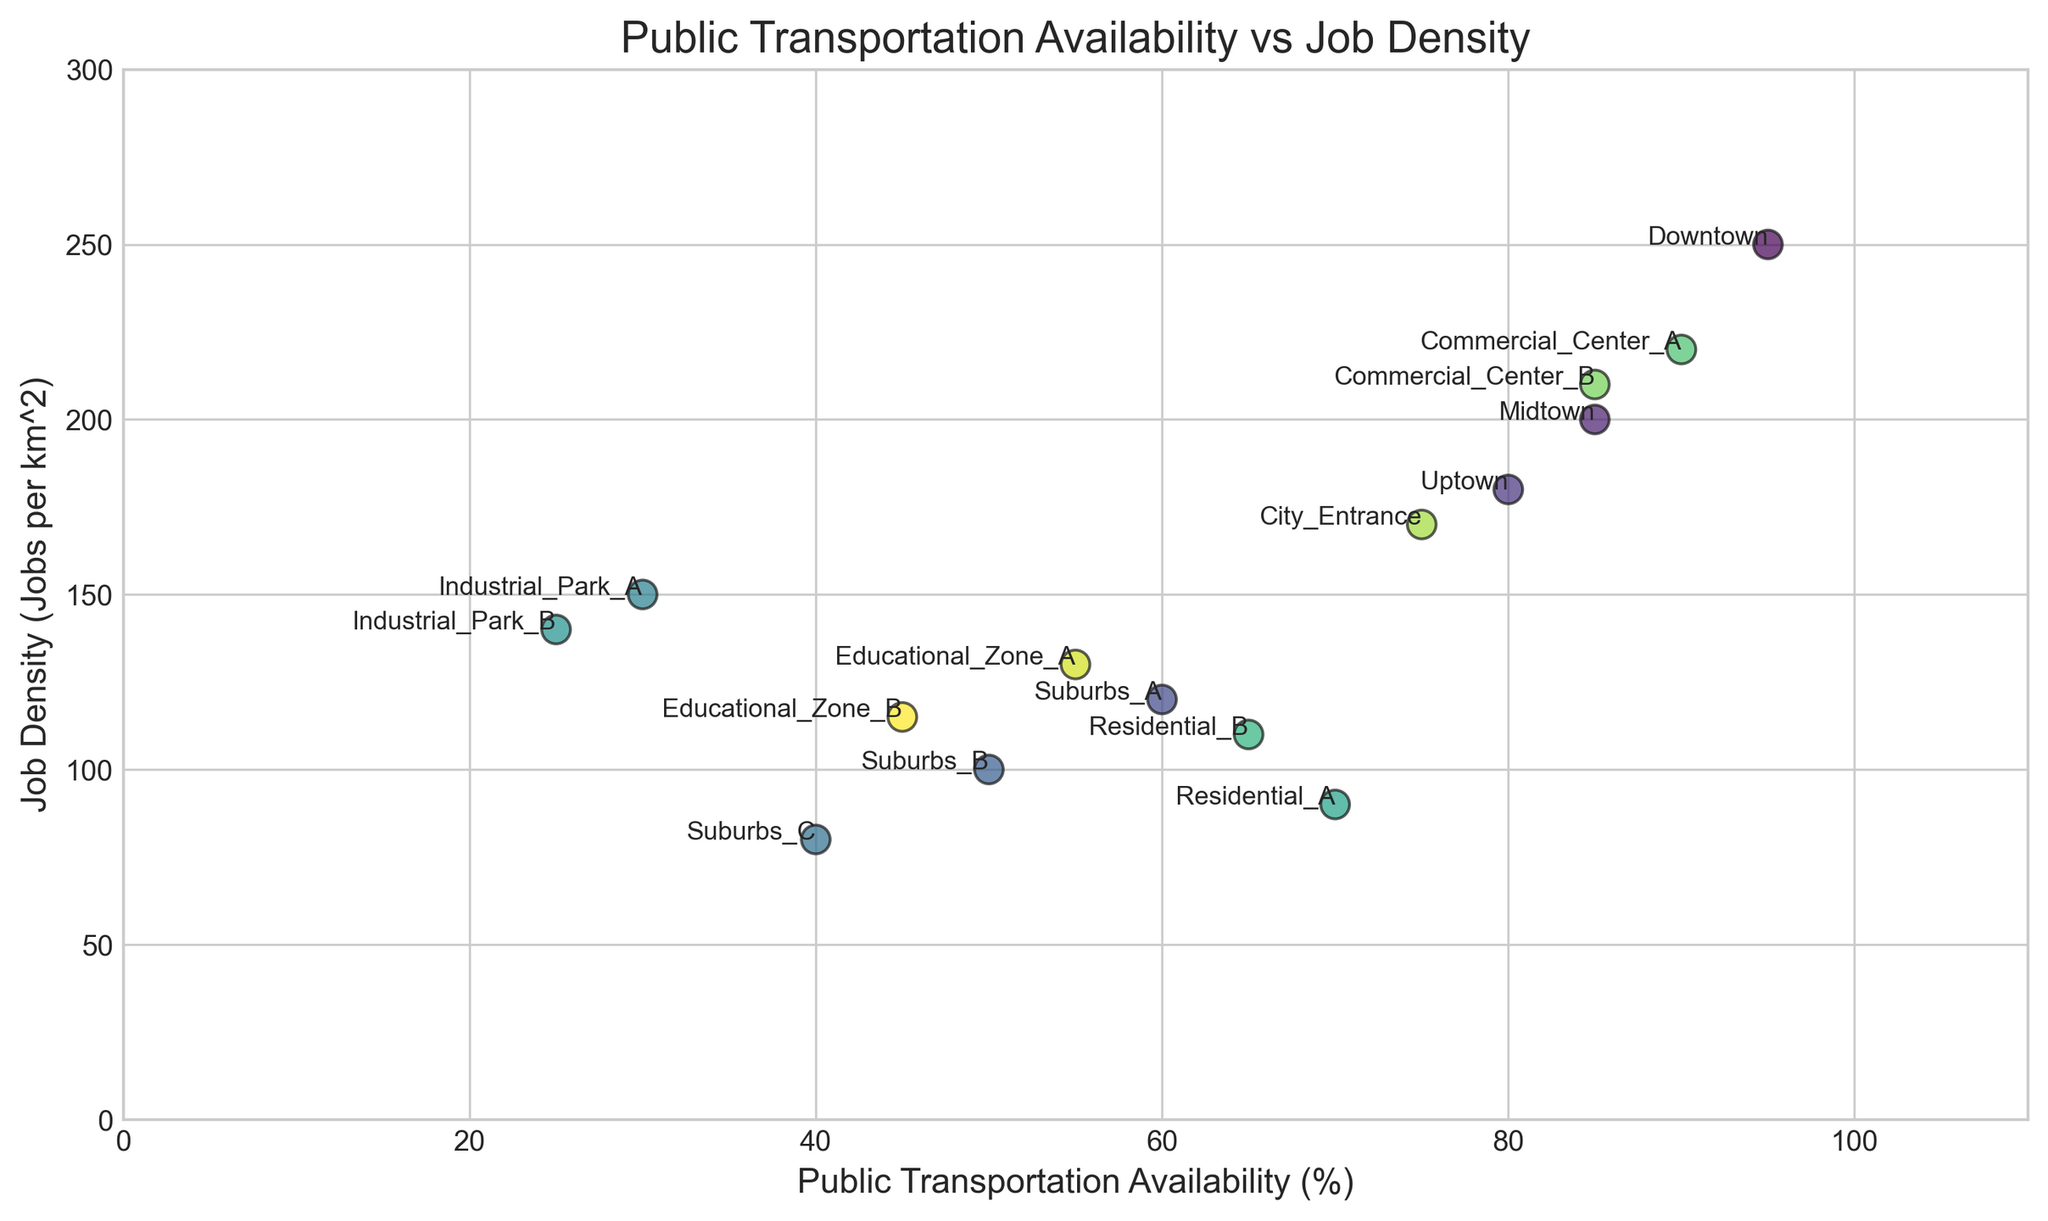What area has the highest job density? Look at the point with the highest vertical position on the y-axis representing job density. The area labeled "Downtown" is at the topmost vertical position indicating it has the highest job density.
Answer: Downtown Which area has the least availability of public transportation? Identify the point with the lowest horizontal position on the x-axis representing public transportation availability. The area labeled "Industrial_Park_B" is at the leftmost horizontal position, showing it has the least public transportation availability.
Answer: Industrial_Park_B Are there any areas where job density exceeds 200 but public transportation availability is below 90? Look for points with a vertical position (job density) more than 200 and a horizontal position (public transportation availability) less than 90. The areas to check are "Midtown" and "Commercial_Center_B". Only "Commercial_Center_B" meets these criteria.
Answer: Commercial_Center_B Which area has both public transportation availability and job density under 100? Look at points where the horizontal position (public transportation availability) and vertical position (job density) are both less than 100. "Suburbs_C" fits this description.
Answer: Suburbs_C What is the difference in public transportation availability between Residential_A and Residential_B? Find the horizontal positions of "Residential_A" (70) and "Residential_B" (65) on the x-axis, then calculate the difference between them, which is 70 - 65.
Answer: 5 Which area has a higher job density, Suburbs_B or Educational_Zone_A? Compare the vertical positions of "Suburbs_B" and "Educational_Zone_A" on the y-axis. "Educational_Zone_A" with a vertical position indicating 130 is higher than "Suburbs_B" with 100.
Answer: Educational_Zone_A How many areas have both public transportation availability greater than 50% and job density less than 150? Count the points with a horizontal position greater than 50 and a vertical position less than 150. These areas are "Uptown", "Residential_A", "Residential_B", and "City_Entrance", totaling 4 areas.
Answer: 4 What is the sum of job densities for the areas with the highest and lowest public transportation availability? The area with the highest public transportation availability is "Downtown" with a job density of 250. The area with the lowest public transportation availability is "Industrial_Park_B" with a job density of 140. The sum is 250 + 140.
Answer: 390 Which has greater job density: an area with 75% public transportation availability or an area with 85%? Identify the job densities for "City_Entrance" (75%, 170) and "Midtown" or "Commercial_Center_B" (85%, 200 or 210). Either "Midtown" or "Commercial_Center_B" have higher job densities than "City_Entrance".
Answer: 85% 